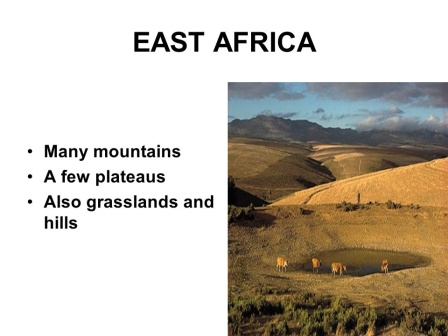Imagine the region had mythical creatures. How would they interact with the environment? Imagine, if you will, mythical creatures inhabiting this East African landscape. Among the hills and valleys, you might encounter majestic Gryphons, their golden feathers glinting in the sunlight as they soar majestically, casting shadows over the plains. In the rivers, great water dragons would glide gracefully, their scales shimmering like gemstones, creating ripples that look like the glistening scales of a serpent. Unicorns would roam among the elephants, their gleaming horns catching the light, lending an ethereal quality to the landscape. The skies would be alive with the vivid colors of Phoenixes, their fiery plumage painting trails of light as they fly. At dusk, when the light softens, you might see Fairies flitting among the flowers, their delicate wings beating in a blur, and Centaurs would emerge from the forests, their powerful forms blending the strength of humans and horses. Each creature would interact with the environment harmoniously, adding a layer of magic to the natural beauty of East Africa, creating a scene straight out of a fantastical dream. 